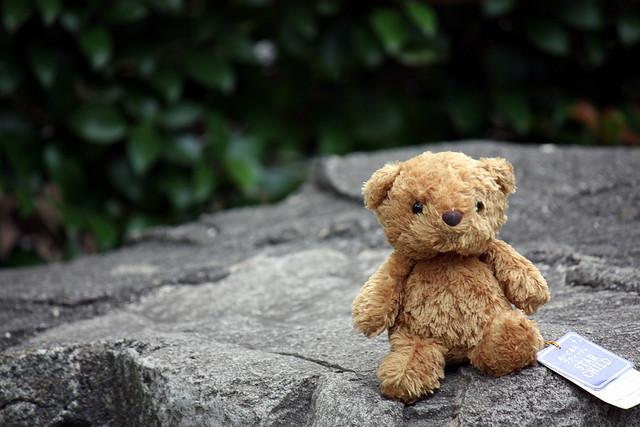Is this a real bear?
Give a very brief answer. No. What color is the bear?
Quick response, please. Brown. Where is the teddy bear sitting?
Keep it brief. On rock. 